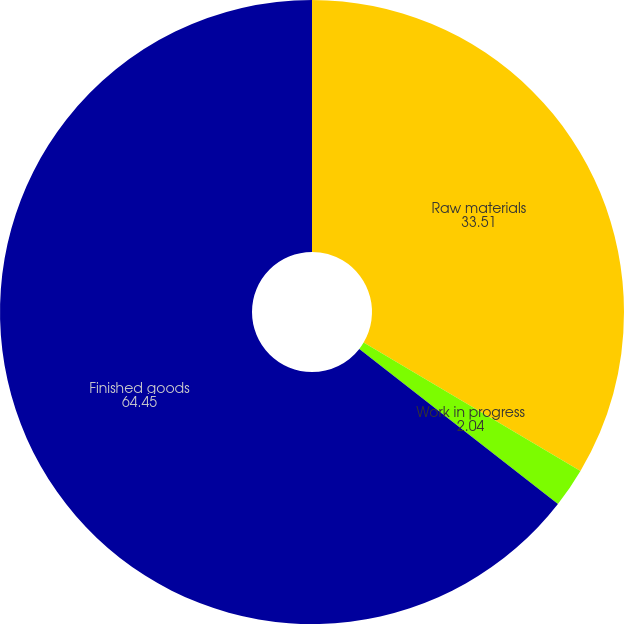<chart> <loc_0><loc_0><loc_500><loc_500><pie_chart><fcel>Raw materials<fcel>Work in progress<fcel>Finished goods<nl><fcel>33.51%<fcel>2.04%<fcel>64.45%<nl></chart> 